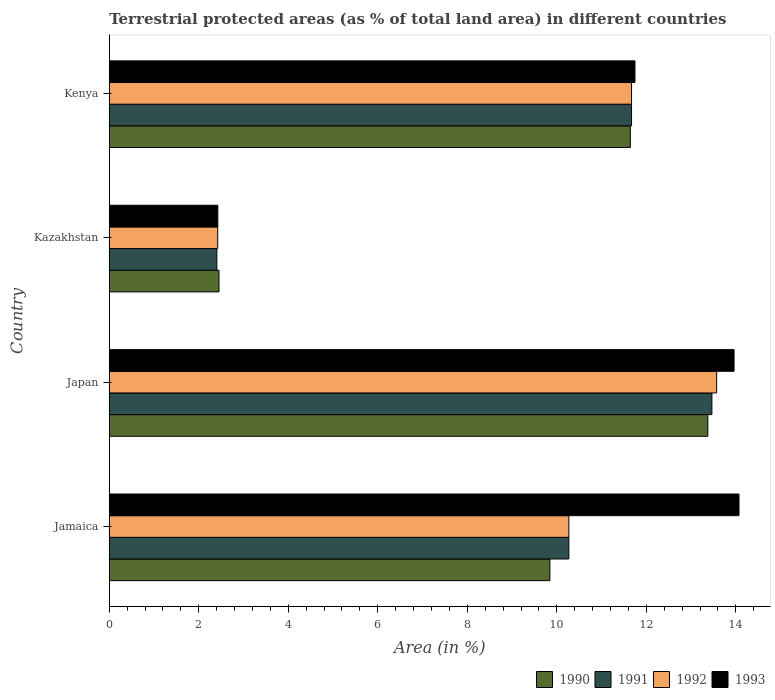How many different coloured bars are there?
Offer a terse response. 4. Are the number of bars per tick equal to the number of legend labels?
Your response must be concise. Yes. How many bars are there on the 4th tick from the top?
Provide a succinct answer. 4. How many bars are there on the 2nd tick from the bottom?
Give a very brief answer. 4. What is the label of the 4th group of bars from the top?
Your answer should be very brief. Jamaica. What is the percentage of terrestrial protected land in 1993 in Jamaica?
Offer a very short reply. 14.07. Across all countries, what is the maximum percentage of terrestrial protected land in 1990?
Offer a very short reply. 13.37. Across all countries, what is the minimum percentage of terrestrial protected land in 1990?
Your response must be concise. 2.45. In which country was the percentage of terrestrial protected land in 1990 minimum?
Keep it short and to the point. Kazakhstan. What is the total percentage of terrestrial protected land in 1991 in the graph?
Provide a succinct answer. 37.81. What is the difference between the percentage of terrestrial protected land in 1991 in Jamaica and that in Kenya?
Make the answer very short. -1.4. What is the difference between the percentage of terrestrial protected land in 1990 in Jamaica and the percentage of terrestrial protected land in 1991 in Kenya?
Make the answer very short. -1.82. What is the average percentage of terrestrial protected land in 1990 per country?
Your answer should be compact. 9.33. What is the difference between the percentage of terrestrial protected land in 1993 and percentage of terrestrial protected land in 1991 in Kazakhstan?
Provide a succinct answer. 0.02. In how many countries, is the percentage of terrestrial protected land in 1990 greater than 12.4 %?
Make the answer very short. 1. What is the ratio of the percentage of terrestrial protected land in 1992 in Jamaica to that in Japan?
Your response must be concise. 0.76. Is the difference between the percentage of terrestrial protected land in 1993 in Jamaica and Kazakhstan greater than the difference between the percentage of terrestrial protected land in 1991 in Jamaica and Kazakhstan?
Your answer should be very brief. Yes. What is the difference between the highest and the second highest percentage of terrestrial protected land in 1991?
Your answer should be compact. 1.8. What is the difference between the highest and the lowest percentage of terrestrial protected land in 1991?
Your response must be concise. 11.06. In how many countries, is the percentage of terrestrial protected land in 1992 greater than the average percentage of terrestrial protected land in 1992 taken over all countries?
Keep it short and to the point. 3. Is it the case that in every country, the sum of the percentage of terrestrial protected land in 1991 and percentage of terrestrial protected land in 1990 is greater than the sum of percentage of terrestrial protected land in 1993 and percentage of terrestrial protected land in 1992?
Your answer should be very brief. No. What does the 4th bar from the top in Japan represents?
Your response must be concise. 1990. What does the 4th bar from the bottom in Japan represents?
Provide a succinct answer. 1993. How many bars are there?
Your response must be concise. 16. Are all the bars in the graph horizontal?
Offer a very short reply. Yes. Does the graph contain any zero values?
Your answer should be compact. No. Where does the legend appear in the graph?
Make the answer very short. Bottom right. How many legend labels are there?
Make the answer very short. 4. What is the title of the graph?
Give a very brief answer. Terrestrial protected areas (as % of total land area) in different countries. What is the label or title of the X-axis?
Keep it short and to the point. Area (in %). What is the label or title of the Y-axis?
Give a very brief answer. Country. What is the Area (in %) of 1990 in Jamaica?
Give a very brief answer. 9.85. What is the Area (in %) in 1991 in Jamaica?
Your answer should be very brief. 10.27. What is the Area (in %) of 1992 in Jamaica?
Make the answer very short. 10.27. What is the Area (in %) in 1993 in Jamaica?
Provide a short and direct response. 14.07. What is the Area (in %) in 1990 in Japan?
Make the answer very short. 13.37. What is the Area (in %) of 1991 in Japan?
Your answer should be compact. 13.47. What is the Area (in %) of 1992 in Japan?
Make the answer very short. 13.57. What is the Area (in %) of 1993 in Japan?
Provide a short and direct response. 13.96. What is the Area (in %) in 1990 in Kazakhstan?
Offer a very short reply. 2.45. What is the Area (in %) in 1991 in Kazakhstan?
Ensure brevity in your answer.  2.4. What is the Area (in %) in 1992 in Kazakhstan?
Provide a short and direct response. 2.42. What is the Area (in %) of 1993 in Kazakhstan?
Your answer should be very brief. 2.43. What is the Area (in %) in 1990 in Kenya?
Your answer should be compact. 11.64. What is the Area (in %) of 1991 in Kenya?
Your answer should be very brief. 11.67. What is the Area (in %) in 1992 in Kenya?
Offer a terse response. 11.67. What is the Area (in %) in 1993 in Kenya?
Offer a very short reply. 11.75. Across all countries, what is the maximum Area (in %) of 1990?
Offer a very short reply. 13.37. Across all countries, what is the maximum Area (in %) of 1991?
Your answer should be very brief. 13.47. Across all countries, what is the maximum Area (in %) of 1992?
Make the answer very short. 13.57. Across all countries, what is the maximum Area (in %) of 1993?
Your answer should be very brief. 14.07. Across all countries, what is the minimum Area (in %) of 1990?
Keep it short and to the point. 2.45. Across all countries, what is the minimum Area (in %) of 1991?
Provide a short and direct response. 2.4. Across all countries, what is the minimum Area (in %) in 1992?
Offer a very short reply. 2.42. Across all countries, what is the minimum Area (in %) in 1993?
Make the answer very short. 2.43. What is the total Area (in %) in 1990 in the graph?
Offer a terse response. 37.32. What is the total Area (in %) in 1991 in the graph?
Your response must be concise. 37.81. What is the total Area (in %) in 1992 in the graph?
Offer a terse response. 37.93. What is the total Area (in %) of 1993 in the graph?
Give a very brief answer. 42.2. What is the difference between the Area (in %) of 1990 in Jamaica and that in Japan?
Offer a very short reply. -3.53. What is the difference between the Area (in %) in 1991 in Jamaica and that in Japan?
Provide a succinct answer. -3.2. What is the difference between the Area (in %) in 1992 in Jamaica and that in Japan?
Your answer should be compact. -3.3. What is the difference between the Area (in %) of 1993 in Jamaica and that in Japan?
Provide a succinct answer. 0.11. What is the difference between the Area (in %) in 1990 in Jamaica and that in Kazakhstan?
Keep it short and to the point. 7.39. What is the difference between the Area (in %) in 1991 in Jamaica and that in Kazakhstan?
Keep it short and to the point. 7.87. What is the difference between the Area (in %) in 1992 in Jamaica and that in Kazakhstan?
Provide a short and direct response. 7.85. What is the difference between the Area (in %) in 1993 in Jamaica and that in Kazakhstan?
Your answer should be very brief. 11.65. What is the difference between the Area (in %) in 1990 in Jamaica and that in Kenya?
Provide a succinct answer. -1.8. What is the difference between the Area (in %) of 1991 in Jamaica and that in Kenya?
Give a very brief answer. -1.4. What is the difference between the Area (in %) in 1992 in Jamaica and that in Kenya?
Provide a succinct answer. -1.4. What is the difference between the Area (in %) of 1993 in Jamaica and that in Kenya?
Offer a terse response. 2.33. What is the difference between the Area (in %) of 1990 in Japan and that in Kazakhstan?
Ensure brevity in your answer.  10.92. What is the difference between the Area (in %) in 1991 in Japan and that in Kazakhstan?
Ensure brevity in your answer.  11.06. What is the difference between the Area (in %) of 1992 in Japan and that in Kazakhstan?
Your answer should be compact. 11.15. What is the difference between the Area (in %) of 1993 in Japan and that in Kazakhstan?
Ensure brevity in your answer.  11.54. What is the difference between the Area (in %) of 1990 in Japan and that in Kenya?
Give a very brief answer. 1.73. What is the difference between the Area (in %) in 1991 in Japan and that in Kenya?
Ensure brevity in your answer.  1.8. What is the difference between the Area (in %) of 1992 in Japan and that in Kenya?
Give a very brief answer. 1.9. What is the difference between the Area (in %) in 1993 in Japan and that in Kenya?
Ensure brevity in your answer.  2.21. What is the difference between the Area (in %) in 1990 in Kazakhstan and that in Kenya?
Make the answer very short. -9.19. What is the difference between the Area (in %) in 1991 in Kazakhstan and that in Kenya?
Your response must be concise. -9.27. What is the difference between the Area (in %) of 1992 in Kazakhstan and that in Kenya?
Give a very brief answer. -9.25. What is the difference between the Area (in %) in 1993 in Kazakhstan and that in Kenya?
Your answer should be compact. -9.32. What is the difference between the Area (in %) of 1990 in Jamaica and the Area (in %) of 1991 in Japan?
Offer a terse response. -3.62. What is the difference between the Area (in %) in 1990 in Jamaica and the Area (in %) in 1992 in Japan?
Make the answer very short. -3.73. What is the difference between the Area (in %) in 1990 in Jamaica and the Area (in %) in 1993 in Japan?
Offer a very short reply. -4.12. What is the difference between the Area (in %) in 1991 in Jamaica and the Area (in %) in 1992 in Japan?
Give a very brief answer. -3.3. What is the difference between the Area (in %) of 1991 in Jamaica and the Area (in %) of 1993 in Japan?
Keep it short and to the point. -3.69. What is the difference between the Area (in %) of 1992 in Jamaica and the Area (in %) of 1993 in Japan?
Give a very brief answer. -3.69. What is the difference between the Area (in %) in 1990 in Jamaica and the Area (in %) in 1991 in Kazakhstan?
Give a very brief answer. 7.44. What is the difference between the Area (in %) in 1990 in Jamaica and the Area (in %) in 1992 in Kazakhstan?
Your response must be concise. 7.42. What is the difference between the Area (in %) of 1990 in Jamaica and the Area (in %) of 1993 in Kazakhstan?
Your answer should be compact. 7.42. What is the difference between the Area (in %) of 1991 in Jamaica and the Area (in %) of 1992 in Kazakhstan?
Your response must be concise. 7.85. What is the difference between the Area (in %) of 1991 in Jamaica and the Area (in %) of 1993 in Kazakhstan?
Give a very brief answer. 7.84. What is the difference between the Area (in %) of 1992 in Jamaica and the Area (in %) of 1993 in Kazakhstan?
Your response must be concise. 7.84. What is the difference between the Area (in %) in 1990 in Jamaica and the Area (in %) in 1991 in Kenya?
Ensure brevity in your answer.  -1.82. What is the difference between the Area (in %) of 1990 in Jamaica and the Area (in %) of 1992 in Kenya?
Give a very brief answer. -1.82. What is the difference between the Area (in %) of 1990 in Jamaica and the Area (in %) of 1993 in Kenya?
Provide a succinct answer. -1.9. What is the difference between the Area (in %) of 1991 in Jamaica and the Area (in %) of 1992 in Kenya?
Ensure brevity in your answer.  -1.4. What is the difference between the Area (in %) of 1991 in Jamaica and the Area (in %) of 1993 in Kenya?
Provide a succinct answer. -1.48. What is the difference between the Area (in %) of 1992 in Jamaica and the Area (in %) of 1993 in Kenya?
Your response must be concise. -1.48. What is the difference between the Area (in %) in 1990 in Japan and the Area (in %) in 1991 in Kazakhstan?
Offer a very short reply. 10.97. What is the difference between the Area (in %) of 1990 in Japan and the Area (in %) of 1992 in Kazakhstan?
Give a very brief answer. 10.95. What is the difference between the Area (in %) of 1990 in Japan and the Area (in %) of 1993 in Kazakhstan?
Keep it short and to the point. 10.95. What is the difference between the Area (in %) in 1991 in Japan and the Area (in %) in 1992 in Kazakhstan?
Offer a terse response. 11.04. What is the difference between the Area (in %) of 1991 in Japan and the Area (in %) of 1993 in Kazakhstan?
Ensure brevity in your answer.  11.04. What is the difference between the Area (in %) in 1992 in Japan and the Area (in %) in 1993 in Kazakhstan?
Offer a very short reply. 11.15. What is the difference between the Area (in %) in 1990 in Japan and the Area (in %) in 1991 in Kenya?
Your answer should be very brief. 1.7. What is the difference between the Area (in %) of 1990 in Japan and the Area (in %) of 1992 in Kenya?
Offer a terse response. 1.7. What is the difference between the Area (in %) in 1990 in Japan and the Area (in %) in 1993 in Kenya?
Offer a very short reply. 1.63. What is the difference between the Area (in %) of 1991 in Japan and the Area (in %) of 1992 in Kenya?
Make the answer very short. 1.8. What is the difference between the Area (in %) of 1991 in Japan and the Area (in %) of 1993 in Kenya?
Provide a succinct answer. 1.72. What is the difference between the Area (in %) in 1992 in Japan and the Area (in %) in 1993 in Kenya?
Give a very brief answer. 1.83. What is the difference between the Area (in %) of 1990 in Kazakhstan and the Area (in %) of 1991 in Kenya?
Give a very brief answer. -9.22. What is the difference between the Area (in %) in 1990 in Kazakhstan and the Area (in %) in 1992 in Kenya?
Give a very brief answer. -9.22. What is the difference between the Area (in %) of 1990 in Kazakhstan and the Area (in %) of 1993 in Kenya?
Your answer should be very brief. -9.29. What is the difference between the Area (in %) in 1991 in Kazakhstan and the Area (in %) in 1992 in Kenya?
Provide a short and direct response. -9.27. What is the difference between the Area (in %) of 1991 in Kazakhstan and the Area (in %) of 1993 in Kenya?
Provide a short and direct response. -9.34. What is the difference between the Area (in %) in 1992 in Kazakhstan and the Area (in %) in 1993 in Kenya?
Keep it short and to the point. -9.32. What is the average Area (in %) of 1990 per country?
Give a very brief answer. 9.33. What is the average Area (in %) of 1991 per country?
Your answer should be compact. 9.45. What is the average Area (in %) of 1992 per country?
Offer a very short reply. 9.48. What is the average Area (in %) of 1993 per country?
Give a very brief answer. 10.55. What is the difference between the Area (in %) in 1990 and Area (in %) in 1991 in Jamaica?
Your answer should be compact. -0.42. What is the difference between the Area (in %) of 1990 and Area (in %) of 1992 in Jamaica?
Your response must be concise. -0.42. What is the difference between the Area (in %) of 1990 and Area (in %) of 1993 in Jamaica?
Make the answer very short. -4.23. What is the difference between the Area (in %) of 1991 and Area (in %) of 1992 in Jamaica?
Your response must be concise. 0. What is the difference between the Area (in %) of 1991 and Area (in %) of 1993 in Jamaica?
Your answer should be compact. -3.8. What is the difference between the Area (in %) of 1992 and Area (in %) of 1993 in Jamaica?
Your answer should be compact. -3.8. What is the difference between the Area (in %) in 1990 and Area (in %) in 1991 in Japan?
Your answer should be compact. -0.09. What is the difference between the Area (in %) in 1990 and Area (in %) in 1992 in Japan?
Provide a short and direct response. -0.2. What is the difference between the Area (in %) in 1990 and Area (in %) in 1993 in Japan?
Your answer should be very brief. -0.59. What is the difference between the Area (in %) of 1991 and Area (in %) of 1992 in Japan?
Your response must be concise. -0.11. What is the difference between the Area (in %) in 1991 and Area (in %) in 1993 in Japan?
Make the answer very short. -0.49. What is the difference between the Area (in %) in 1992 and Area (in %) in 1993 in Japan?
Provide a short and direct response. -0.39. What is the difference between the Area (in %) in 1990 and Area (in %) in 1991 in Kazakhstan?
Give a very brief answer. 0.05. What is the difference between the Area (in %) in 1990 and Area (in %) in 1992 in Kazakhstan?
Ensure brevity in your answer.  0.03. What is the difference between the Area (in %) of 1990 and Area (in %) of 1993 in Kazakhstan?
Your response must be concise. 0.03. What is the difference between the Area (in %) in 1991 and Area (in %) in 1992 in Kazakhstan?
Make the answer very short. -0.02. What is the difference between the Area (in %) of 1991 and Area (in %) of 1993 in Kazakhstan?
Offer a very short reply. -0.02. What is the difference between the Area (in %) of 1992 and Area (in %) of 1993 in Kazakhstan?
Your answer should be compact. -0. What is the difference between the Area (in %) in 1990 and Area (in %) in 1991 in Kenya?
Your response must be concise. -0.03. What is the difference between the Area (in %) of 1990 and Area (in %) of 1992 in Kenya?
Provide a short and direct response. -0.03. What is the difference between the Area (in %) of 1990 and Area (in %) of 1993 in Kenya?
Ensure brevity in your answer.  -0.1. What is the difference between the Area (in %) in 1991 and Area (in %) in 1992 in Kenya?
Offer a terse response. -0. What is the difference between the Area (in %) of 1991 and Area (in %) of 1993 in Kenya?
Ensure brevity in your answer.  -0.08. What is the difference between the Area (in %) in 1992 and Area (in %) in 1993 in Kenya?
Give a very brief answer. -0.08. What is the ratio of the Area (in %) in 1990 in Jamaica to that in Japan?
Your answer should be very brief. 0.74. What is the ratio of the Area (in %) of 1991 in Jamaica to that in Japan?
Provide a short and direct response. 0.76. What is the ratio of the Area (in %) in 1992 in Jamaica to that in Japan?
Give a very brief answer. 0.76. What is the ratio of the Area (in %) in 1993 in Jamaica to that in Japan?
Offer a very short reply. 1.01. What is the ratio of the Area (in %) of 1990 in Jamaica to that in Kazakhstan?
Provide a short and direct response. 4.02. What is the ratio of the Area (in %) of 1991 in Jamaica to that in Kazakhstan?
Your answer should be compact. 4.27. What is the ratio of the Area (in %) of 1992 in Jamaica to that in Kazakhstan?
Ensure brevity in your answer.  4.24. What is the ratio of the Area (in %) in 1993 in Jamaica to that in Kazakhstan?
Your answer should be very brief. 5.8. What is the ratio of the Area (in %) in 1990 in Jamaica to that in Kenya?
Give a very brief answer. 0.85. What is the ratio of the Area (in %) of 1991 in Jamaica to that in Kenya?
Offer a very short reply. 0.88. What is the ratio of the Area (in %) in 1992 in Jamaica to that in Kenya?
Your answer should be compact. 0.88. What is the ratio of the Area (in %) in 1993 in Jamaica to that in Kenya?
Your answer should be very brief. 1.2. What is the ratio of the Area (in %) of 1990 in Japan to that in Kazakhstan?
Your answer should be compact. 5.45. What is the ratio of the Area (in %) in 1991 in Japan to that in Kazakhstan?
Offer a terse response. 5.6. What is the ratio of the Area (in %) in 1992 in Japan to that in Kazakhstan?
Your response must be concise. 5.6. What is the ratio of the Area (in %) in 1993 in Japan to that in Kazakhstan?
Make the answer very short. 5.76. What is the ratio of the Area (in %) of 1990 in Japan to that in Kenya?
Ensure brevity in your answer.  1.15. What is the ratio of the Area (in %) in 1991 in Japan to that in Kenya?
Offer a very short reply. 1.15. What is the ratio of the Area (in %) of 1992 in Japan to that in Kenya?
Provide a succinct answer. 1.16. What is the ratio of the Area (in %) of 1993 in Japan to that in Kenya?
Provide a short and direct response. 1.19. What is the ratio of the Area (in %) in 1990 in Kazakhstan to that in Kenya?
Provide a short and direct response. 0.21. What is the ratio of the Area (in %) of 1991 in Kazakhstan to that in Kenya?
Provide a succinct answer. 0.21. What is the ratio of the Area (in %) of 1992 in Kazakhstan to that in Kenya?
Offer a very short reply. 0.21. What is the ratio of the Area (in %) in 1993 in Kazakhstan to that in Kenya?
Provide a short and direct response. 0.21. What is the difference between the highest and the second highest Area (in %) in 1990?
Provide a succinct answer. 1.73. What is the difference between the highest and the second highest Area (in %) of 1991?
Offer a very short reply. 1.8. What is the difference between the highest and the second highest Area (in %) in 1992?
Offer a terse response. 1.9. What is the difference between the highest and the second highest Area (in %) in 1993?
Your response must be concise. 0.11. What is the difference between the highest and the lowest Area (in %) of 1990?
Your answer should be compact. 10.92. What is the difference between the highest and the lowest Area (in %) of 1991?
Your answer should be very brief. 11.06. What is the difference between the highest and the lowest Area (in %) of 1992?
Your response must be concise. 11.15. What is the difference between the highest and the lowest Area (in %) of 1993?
Offer a terse response. 11.65. 